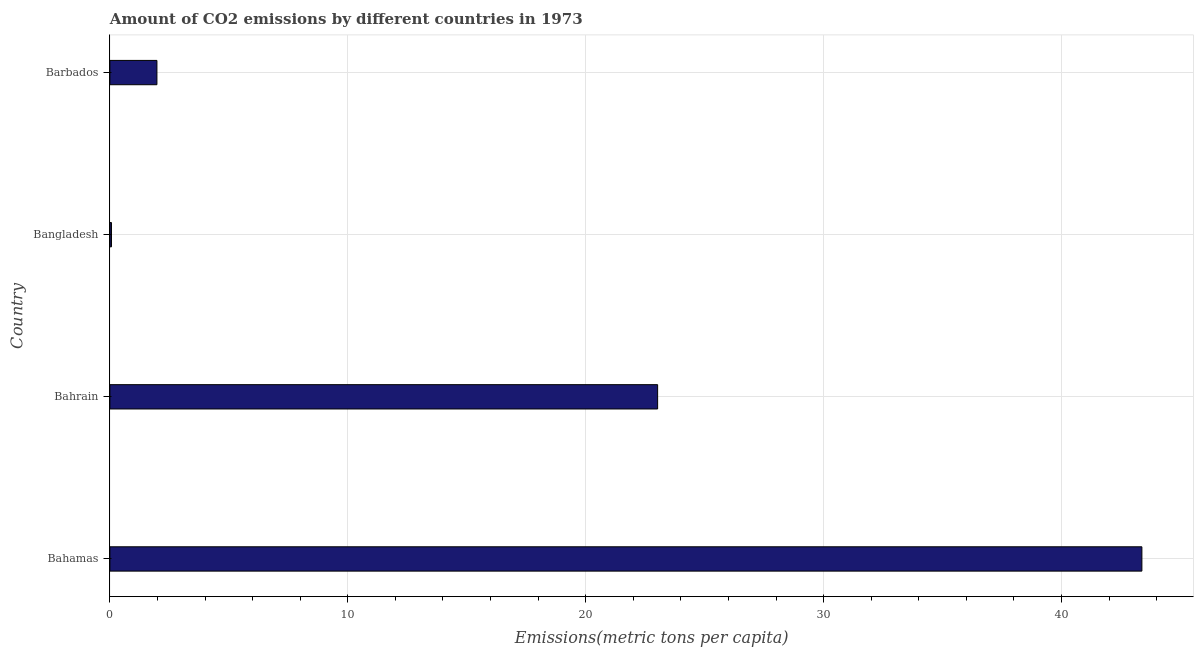Does the graph contain any zero values?
Ensure brevity in your answer.  No. What is the title of the graph?
Your answer should be compact. Amount of CO2 emissions by different countries in 1973. What is the label or title of the X-axis?
Provide a succinct answer. Emissions(metric tons per capita). What is the amount of co2 emissions in Barbados?
Provide a succinct answer. 1.98. Across all countries, what is the maximum amount of co2 emissions?
Keep it short and to the point. 43.38. Across all countries, what is the minimum amount of co2 emissions?
Provide a succinct answer. 0.07. In which country was the amount of co2 emissions maximum?
Give a very brief answer. Bahamas. In which country was the amount of co2 emissions minimum?
Provide a succinct answer. Bangladesh. What is the sum of the amount of co2 emissions?
Your answer should be compact. 68.45. What is the difference between the amount of co2 emissions in Bangladesh and Barbados?
Offer a terse response. -1.91. What is the average amount of co2 emissions per country?
Provide a short and direct response. 17.11. What is the median amount of co2 emissions?
Your answer should be compact. 12.5. What is the ratio of the amount of co2 emissions in Bahamas to that in Bangladesh?
Your answer should be compact. 653.97. Is the amount of co2 emissions in Bahamas less than that in Barbados?
Your answer should be compact. No. What is the difference between the highest and the second highest amount of co2 emissions?
Offer a terse response. 20.36. Is the sum of the amount of co2 emissions in Bangladesh and Barbados greater than the maximum amount of co2 emissions across all countries?
Make the answer very short. No. What is the difference between the highest and the lowest amount of co2 emissions?
Make the answer very short. 43.31. In how many countries, is the amount of co2 emissions greater than the average amount of co2 emissions taken over all countries?
Ensure brevity in your answer.  2. How many bars are there?
Offer a very short reply. 4. Are all the bars in the graph horizontal?
Provide a succinct answer. Yes. How many countries are there in the graph?
Your answer should be very brief. 4. Are the values on the major ticks of X-axis written in scientific E-notation?
Provide a short and direct response. No. What is the Emissions(metric tons per capita) in Bahamas?
Offer a very short reply. 43.38. What is the Emissions(metric tons per capita) of Bahrain?
Your answer should be very brief. 23.02. What is the Emissions(metric tons per capita) of Bangladesh?
Make the answer very short. 0.07. What is the Emissions(metric tons per capita) of Barbados?
Ensure brevity in your answer.  1.98. What is the difference between the Emissions(metric tons per capita) in Bahamas and Bahrain?
Offer a terse response. 20.36. What is the difference between the Emissions(metric tons per capita) in Bahamas and Bangladesh?
Your answer should be very brief. 43.31. What is the difference between the Emissions(metric tons per capita) in Bahamas and Barbados?
Your response must be concise. 41.4. What is the difference between the Emissions(metric tons per capita) in Bahrain and Bangladesh?
Keep it short and to the point. 22.96. What is the difference between the Emissions(metric tons per capita) in Bahrain and Barbados?
Keep it short and to the point. 21.05. What is the difference between the Emissions(metric tons per capita) in Bangladesh and Barbados?
Give a very brief answer. -1.91. What is the ratio of the Emissions(metric tons per capita) in Bahamas to that in Bahrain?
Offer a terse response. 1.88. What is the ratio of the Emissions(metric tons per capita) in Bahamas to that in Bangladesh?
Make the answer very short. 653.97. What is the ratio of the Emissions(metric tons per capita) in Bahamas to that in Barbados?
Ensure brevity in your answer.  21.94. What is the ratio of the Emissions(metric tons per capita) in Bahrain to that in Bangladesh?
Keep it short and to the point. 347.09. What is the ratio of the Emissions(metric tons per capita) in Bahrain to that in Barbados?
Provide a short and direct response. 11.65. What is the ratio of the Emissions(metric tons per capita) in Bangladesh to that in Barbados?
Keep it short and to the point. 0.03. 